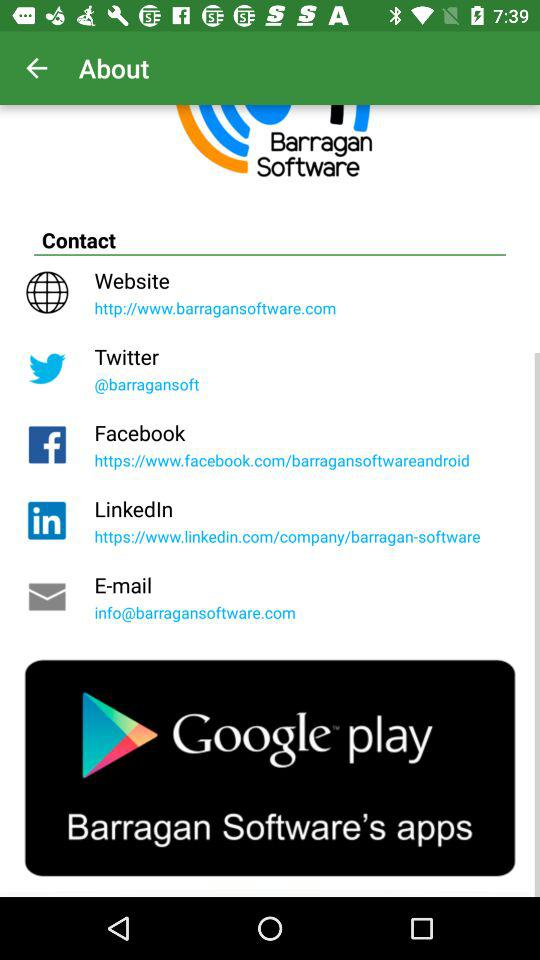What is the website of the company? The website of the company is http://www.barragansoftware.com. 